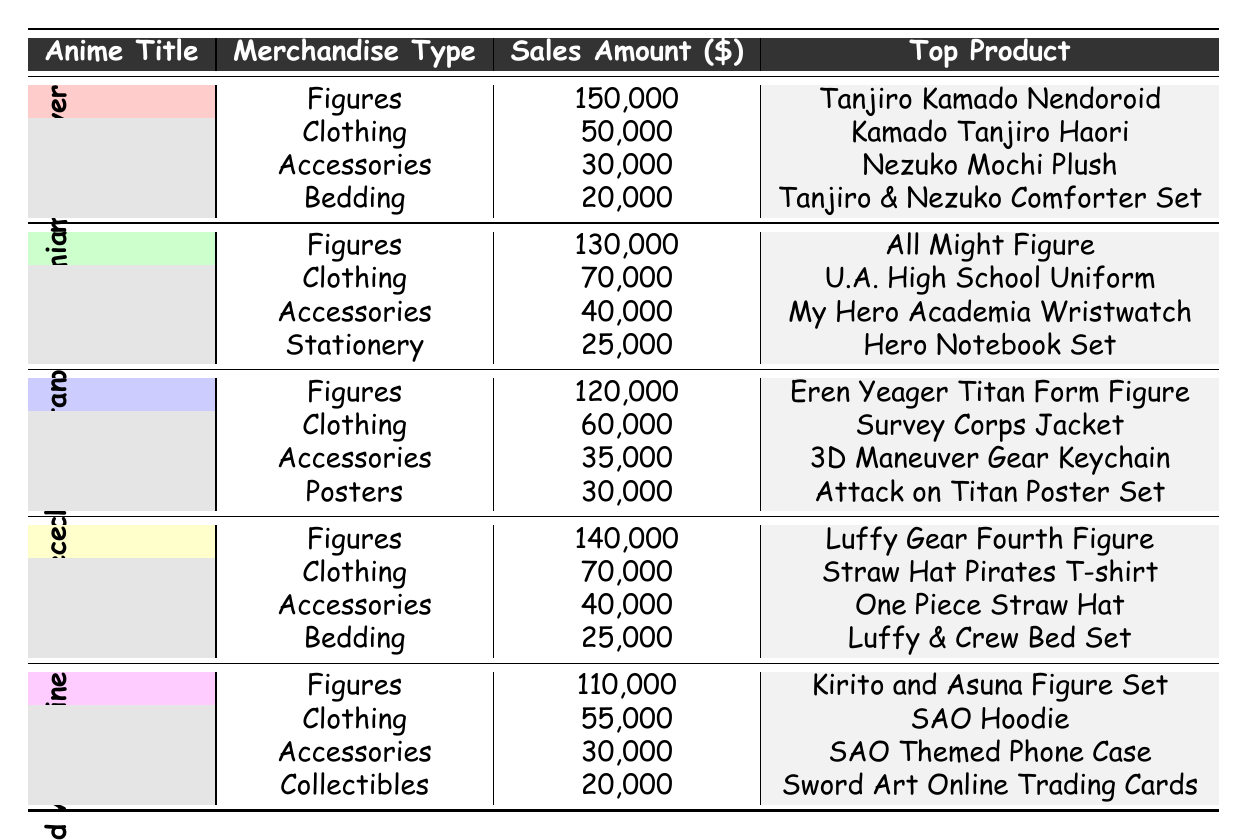What is the top-selling figure in Demon Slayer: Kimetsu no Yaiba? According to the table, the merchandise type for Demon Slayer is listed, and the figures section shows that the top-selling figure is the Tanjiro Kamado Nendoroid with a sales amount of 150,000.
Answer: Tanjiro Kamado Nendoroid Which anime series has the highest sales for clothing? The clothing sales amounts provided in the table are 50,000 for Demon Slayer, 70,000 for My Hero Academia, 60,000 for Attack on Titan, 70,000 for One Piece, and 55,000 for Sword Art Online. Comparing these, both My Hero Academia and One Piece have the highest clothing sales of 70,000.
Answer: My Hero Academia and One Piece What is the total sales amount for accessories across all anime series? To find the total sales amount for accessories, we sum the sales amounts: 30,000 (Demon Slayer) + 40,000 (My Hero Academia) + 35,000 (Attack on Titan) + 40,000 (One Piece) + 30,000 (Sword Art Online) = 215,000.
Answer: 215,000 Is the top product for One Piece a figure? The top product for One Piece is the Luffy Gear Fourth Figure. Since this is categorized under figures, the statement is true.
Answer: Yes If we rank the sales amounts for figures from highest to lowest, what is the median figure sales amount? The sales amounts for figures are 150,000 (Demon Slayer), 130,000 (My Hero Academia), 120,000 (Attack on Titan), 140,000 (One Piece), and 110,000 (Sword Art Online). Arranging these in order gives us 110,000, 120,000, 130,000, 140,000, and 150,000. The middle value, or median, is the third value, which is 130,000.
Answer: 130,000 